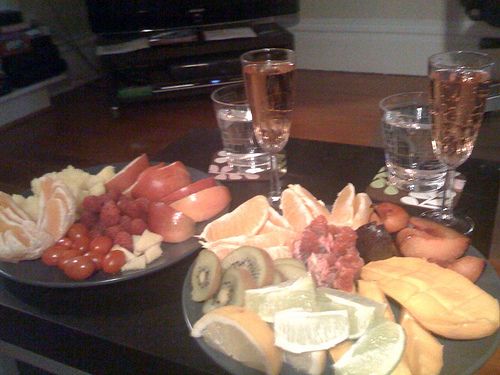What types of fruit can be seen in the image? The image features a variety of fruits including orange slices, kiwi, grapes, cherries or small tomatoes, and what appears to be sliced mango. 